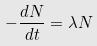Convert formula to latex. <formula><loc_0><loc_0><loc_500><loc_500>- \frac { d N } { d t } = \lambda N</formula> 